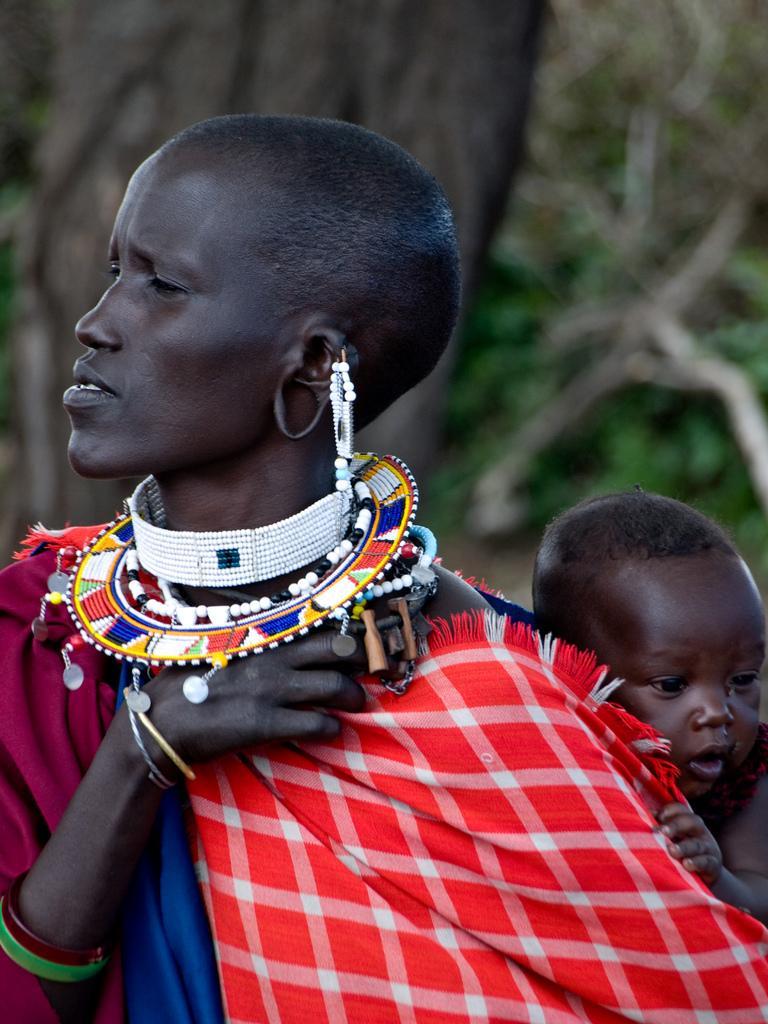In one or two sentences, can you explain what this image depicts? In this picture I can see a woman in front and I see that she is carrying a baby and I can also see that she is wearing colorful ornaments and I see that it is blurred in the background. 